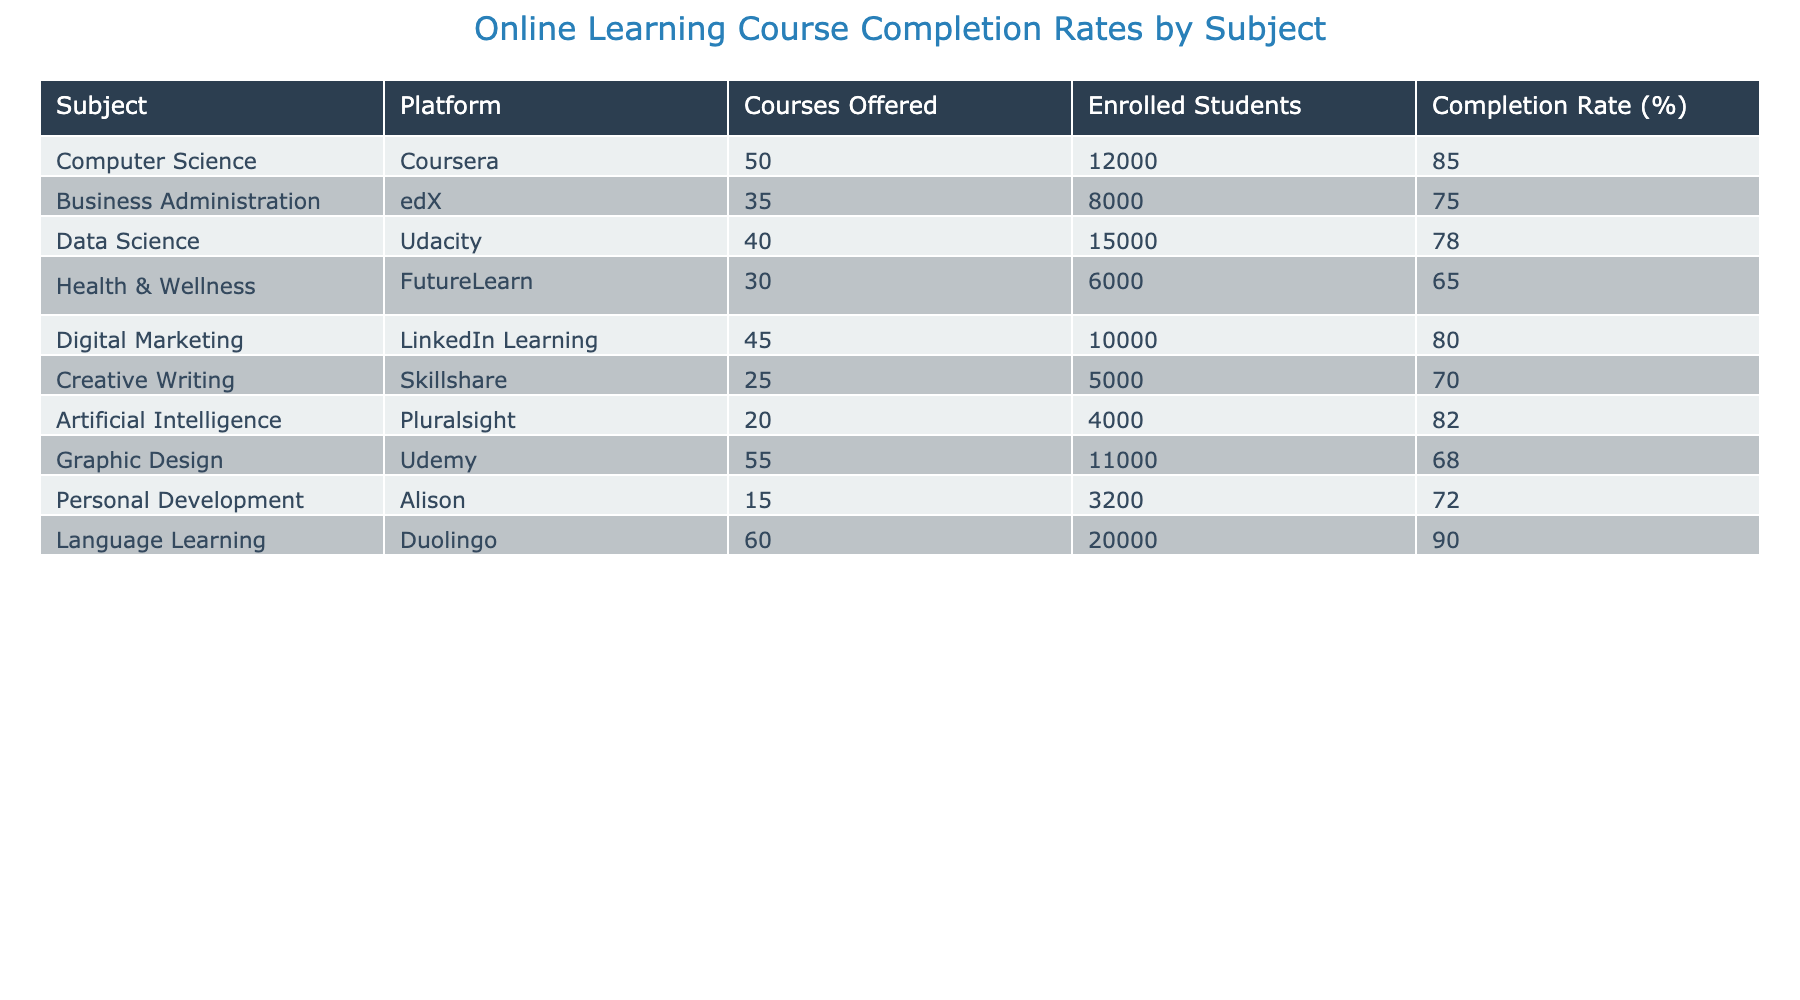What is the completion rate for Language Learning courses? The table lists the completion rate for Language Learning courses as 90%. This value is directly seen in the completion rate column for the row labeled Language Learning.
Answer: 90% Which subject has the highest enrollment of students? The subject with the highest enrollment is Language Learning, with 20,000 enrolled students. This can be found by comparing the Enrolled Students column values across all subjects.
Answer: Language Learning What is the average completion rate for the courses in Creative Writing and Health & Wellness? The completion rates for Creative Writing and Health & Wellness are 70% and 65% respectively. To find the average, we add these two rates: 70 + 65 = 135, and then divide by 2 to get an average of 67.5%.
Answer: 67.5% Is the completion rate for Data Science higher than that of Business Administration? The completion rate for Data Science is 78%, while it is 75% for Business Administration. Since 78 is greater than 75, the answer is yes.
Answer: Yes If we consider all subjects, what is the total number of enrolled students across all courses? To find the total, we sum the number of enrolled students in each subject: 12000 + 8000 + 15000 + 6000 + 10000 + 5000 + 4000 + 11000 + 3200 + 20000 = 101200. Thus, the total number of enrolled students is 101200.
Answer: 101200 Which subject has the lowest completion rate? The subject with the lowest completion rate is Health & Wellness, which has a completion rate of 65%, as indicated in the completion rate column for that row.
Answer: Health & Wellness How many platforms have a completion rate above 80%? The subjects with completion rates over 80% are Computer Science (85%), Digital Marketing (80%), Artificial Intelligence (82%), and Language Learning (90%). That is a total of 4 subjects with completion rates above 80%.
Answer: 4 Calculate the difference in enrollment between Computer Science and Graphic Design. The enrollment for Computer Science is 12,000, and for Graphic Design, it is 11,000. The difference in enrollment is calculated by subtracting the enrollment of Graphic Design from that of Computer Science: 12000 - 11000 = 1000.
Answer: 1000 What is the total number of courses offered on the platform with the highest completion rate? Language Learning has the highest completion rate at 90%, with 60 courses offered. Therefore, the total number of courses offered on the platform with this completion rate is 60.
Answer: 60 